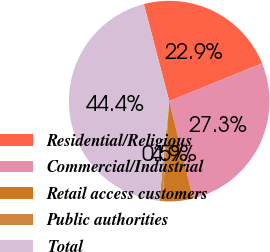Convert chart to OTSL. <chart><loc_0><loc_0><loc_500><loc_500><pie_chart><fcel>Residential/Religious<fcel>Commercial/Industrial<fcel>Retail access customers<fcel>Public authorities<fcel>Total<nl><fcel>22.93%<fcel>27.32%<fcel>4.89%<fcel>0.5%<fcel>44.37%<nl></chart> 